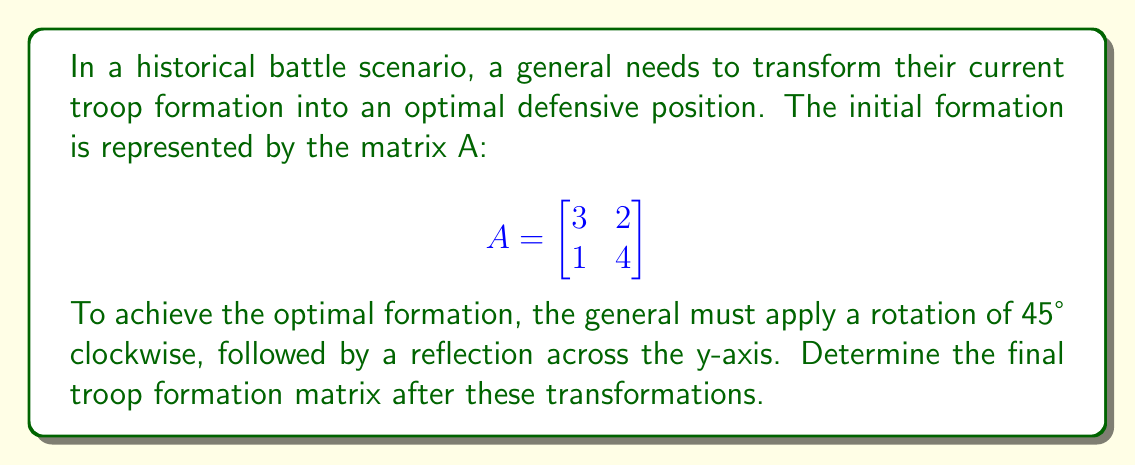Provide a solution to this math problem. Let's approach this step-by-step:

1) First, we need to recall the matrices for rotation and reflection:

   Rotation by θ clockwise: 
   $$R_θ = \begin{bmatrix}
   \cos θ & \sin θ \\
   -\sin θ & \cos θ
   \end{bmatrix}$$

   Reflection across y-axis:
   $$R_y = \begin{bmatrix}
   -1 & 0 \\
   0 & 1
   \end{bmatrix}$$

2) For a 45° rotation, θ = 45° = π/4 radians. We know that:
   $\cos(π/4) = \sin(π/4) = \frac{1}{\sqrt{2}}$

3) So, our rotation matrix is:
   $$R_{45°} = \begin{bmatrix}
   \frac{1}{\sqrt{2}} & \frac{1}{\sqrt{2}} \\
   -\frac{1}{\sqrt{2}} & \frac{1}{\sqrt{2}}
   \end{bmatrix}$$

4) The transformation is applied in the order: Rotation, then Reflection. In matrix notation, this is:
   $R_y \cdot R_{45°} \cdot A$

5) Let's calculate step by step:
   First, $R_{45°} \cdot A$:
   $$\begin{bmatrix}
   \frac{1}{\sqrt{2}} & \frac{1}{\sqrt{2}} \\
   -\frac{1}{\sqrt{2}} & \frac{1}{\sqrt{2}}
   \end{bmatrix} \cdot 
   \begin{bmatrix}
   3 & 2 \\
   1 & 4
   \end{bmatrix} = 
   \begin{bmatrix}
   \frac{3+1}{\sqrt{2}} & \frac{2+4}{\sqrt{2}} \\
   \frac{-3+1}{\sqrt{2}} & \frac{-2+4}{\sqrt{2}}
   \end{bmatrix} = 
   \begin{bmatrix}
   2\sqrt{2} & 3\sqrt{2} \\
   -\sqrt{2} & \sqrt{2}
   \end{bmatrix}$$

6) Now, we apply the reflection:
   $$\begin{bmatrix}
   -1 & 0 \\
   0 & 1
   \end{bmatrix} \cdot 
   \begin{bmatrix}
   2\sqrt{2} & 3\sqrt{2} \\
   -\sqrt{2} & \sqrt{2}
   \end{bmatrix} = 
   \begin{bmatrix}
   -2\sqrt{2} & -3\sqrt{2} \\
   -\sqrt{2} & \sqrt{2}
   \end{bmatrix}$$

This is our final troop formation matrix.
Answer: The final troop formation matrix after the transformations is:
$$\begin{bmatrix}
-2\sqrt{2} & -3\sqrt{2} \\
-\sqrt{2} & \sqrt{2}
\end{bmatrix}$$ 